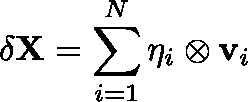<formula> <loc_0><loc_0><loc_500><loc_500>\delta { X } = \sum _ { i = 1 } ^ { N } { \eta } _ { i } \otimes { v } _ { i }</formula> 